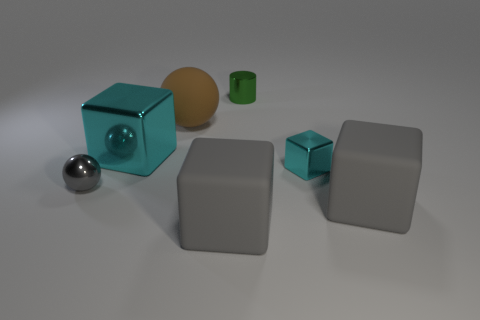Does the small cyan object have the same shape as the big brown thing? No, the small cyan object has a cubic shape, whereas the big brown object is an orb, round and entirely smooth with no edges or vertices. 